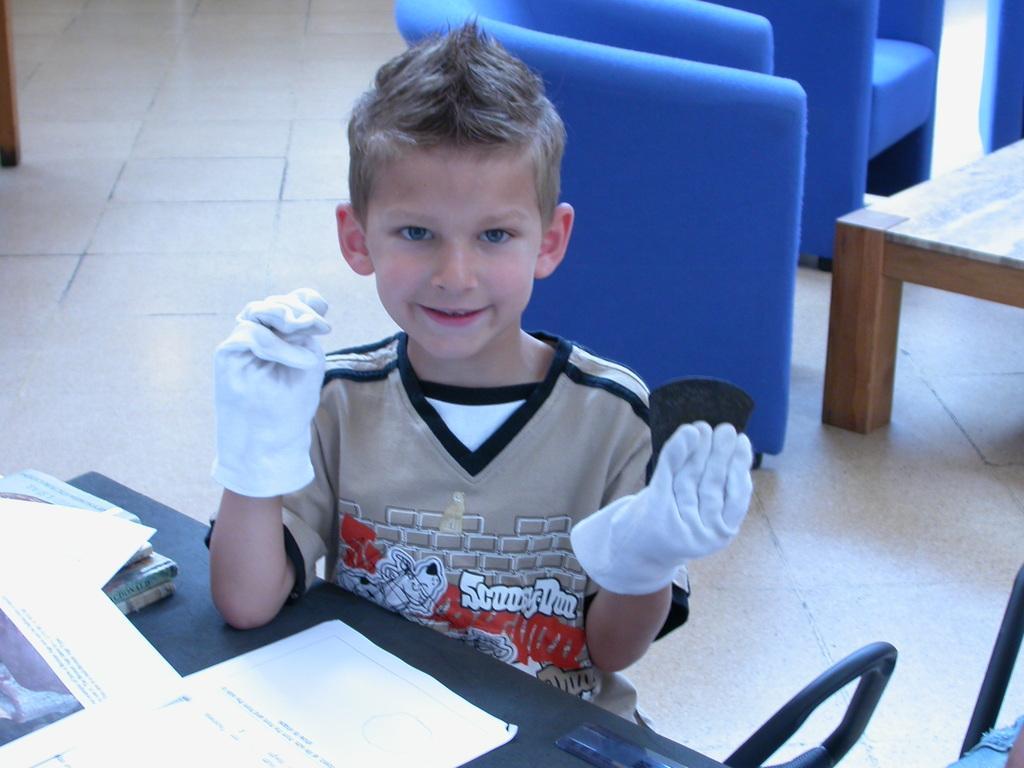Describe this image in one or two sentences. In the picture we can see a boy sitting near the desk and he is with white gloves, and funky hairstyle and on the desk, we can see some papers and behind the boy we can see some chairs which are blue in color and a part of the bench on the floor. 